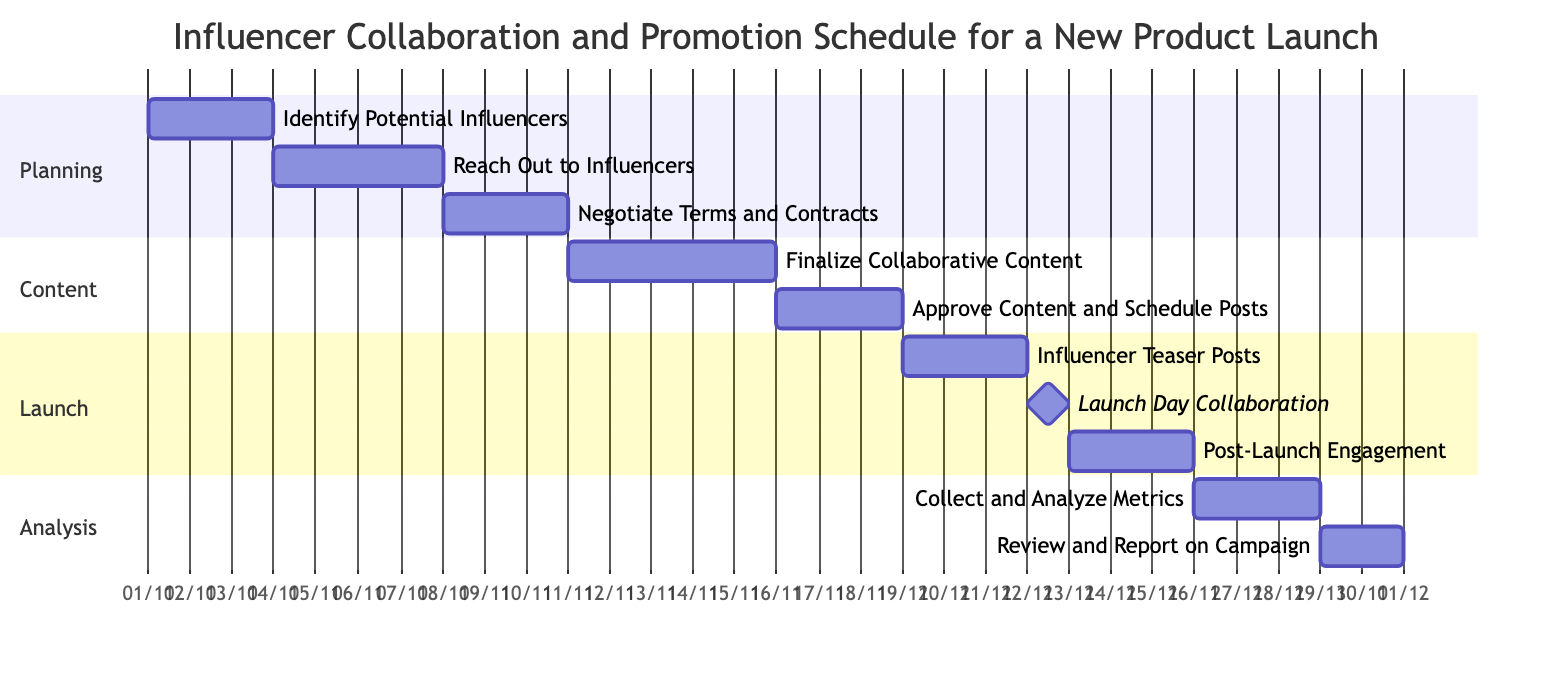What is the duration of the "Identify Potential Influencers" task? The task "Identify Potential Influencers" starts on November 1, 2023, and ends on November 3, 2023. This duration is 3 days.
Answer: 3 days Which task begins immediately after "Reach Out to Influencers"? "Negotiate Terms and Contracts" follows "Reach Out to Influencers" without any delay. Since "Reach Out to Influencers" ends on November 7, 2023, "Negotiate Terms and Contracts" starts on November 8, 2023.
Answer: Negotiate Terms and Contracts How many days are allocated for "Finalize Collaborative Content"? The task "Finalize Collaborative Content" starts on November 11, 2023, and ends on November 15, 2023. This gives it a duration of 5 days.
Answer: 5 days What task is a milestone in the launch section? A milestone is a significant event within the project timeline. In this Gantt chart, "Launch Day Collaboration" is marked as a milestone, indicating a crucial point in the schedule.
Answer: Launch Day Collaboration What is the gap between "Approve Content and Schedule Posts" and "Influencer Teaser Posts"? "Approve Content and Schedule Posts" ends on November 18, 2023, and "Influencer Teaser Posts" starts on November 19, 2023. There is no gap between these two tasks, as "Influencer Teaser Posts" begins the day after "Approve Content and Schedule Posts" ends.
Answer: 0 days What task occurs immediately after "Post-Launch Engagement"? Following "Post-Launch Engagement," which ends on November 25, 2023, the next task is "Collect and Analyze Metrics," which begins on November 26, 2023.
Answer: Collect and Analyze Metrics How many total tasks are included in the Gantt chart? The chart lists ten distinct tasks, covering a complete workflow from planning to analysis for the influencer collaboration and promotion schedule.
Answer: 10 tasks On what date does the "Launch Day Collaboration" task take place? "Launch Day Collaboration" is a one-day milestone that is scheduled for November 22, 2023.
Answer: November 22, 2023 What is the last task in the Gantt chart? The final task in the schedule is "Review and Report on Campaign," which happens from November 29 to November 30, 2023.
Answer: Review and Report on Campaign 